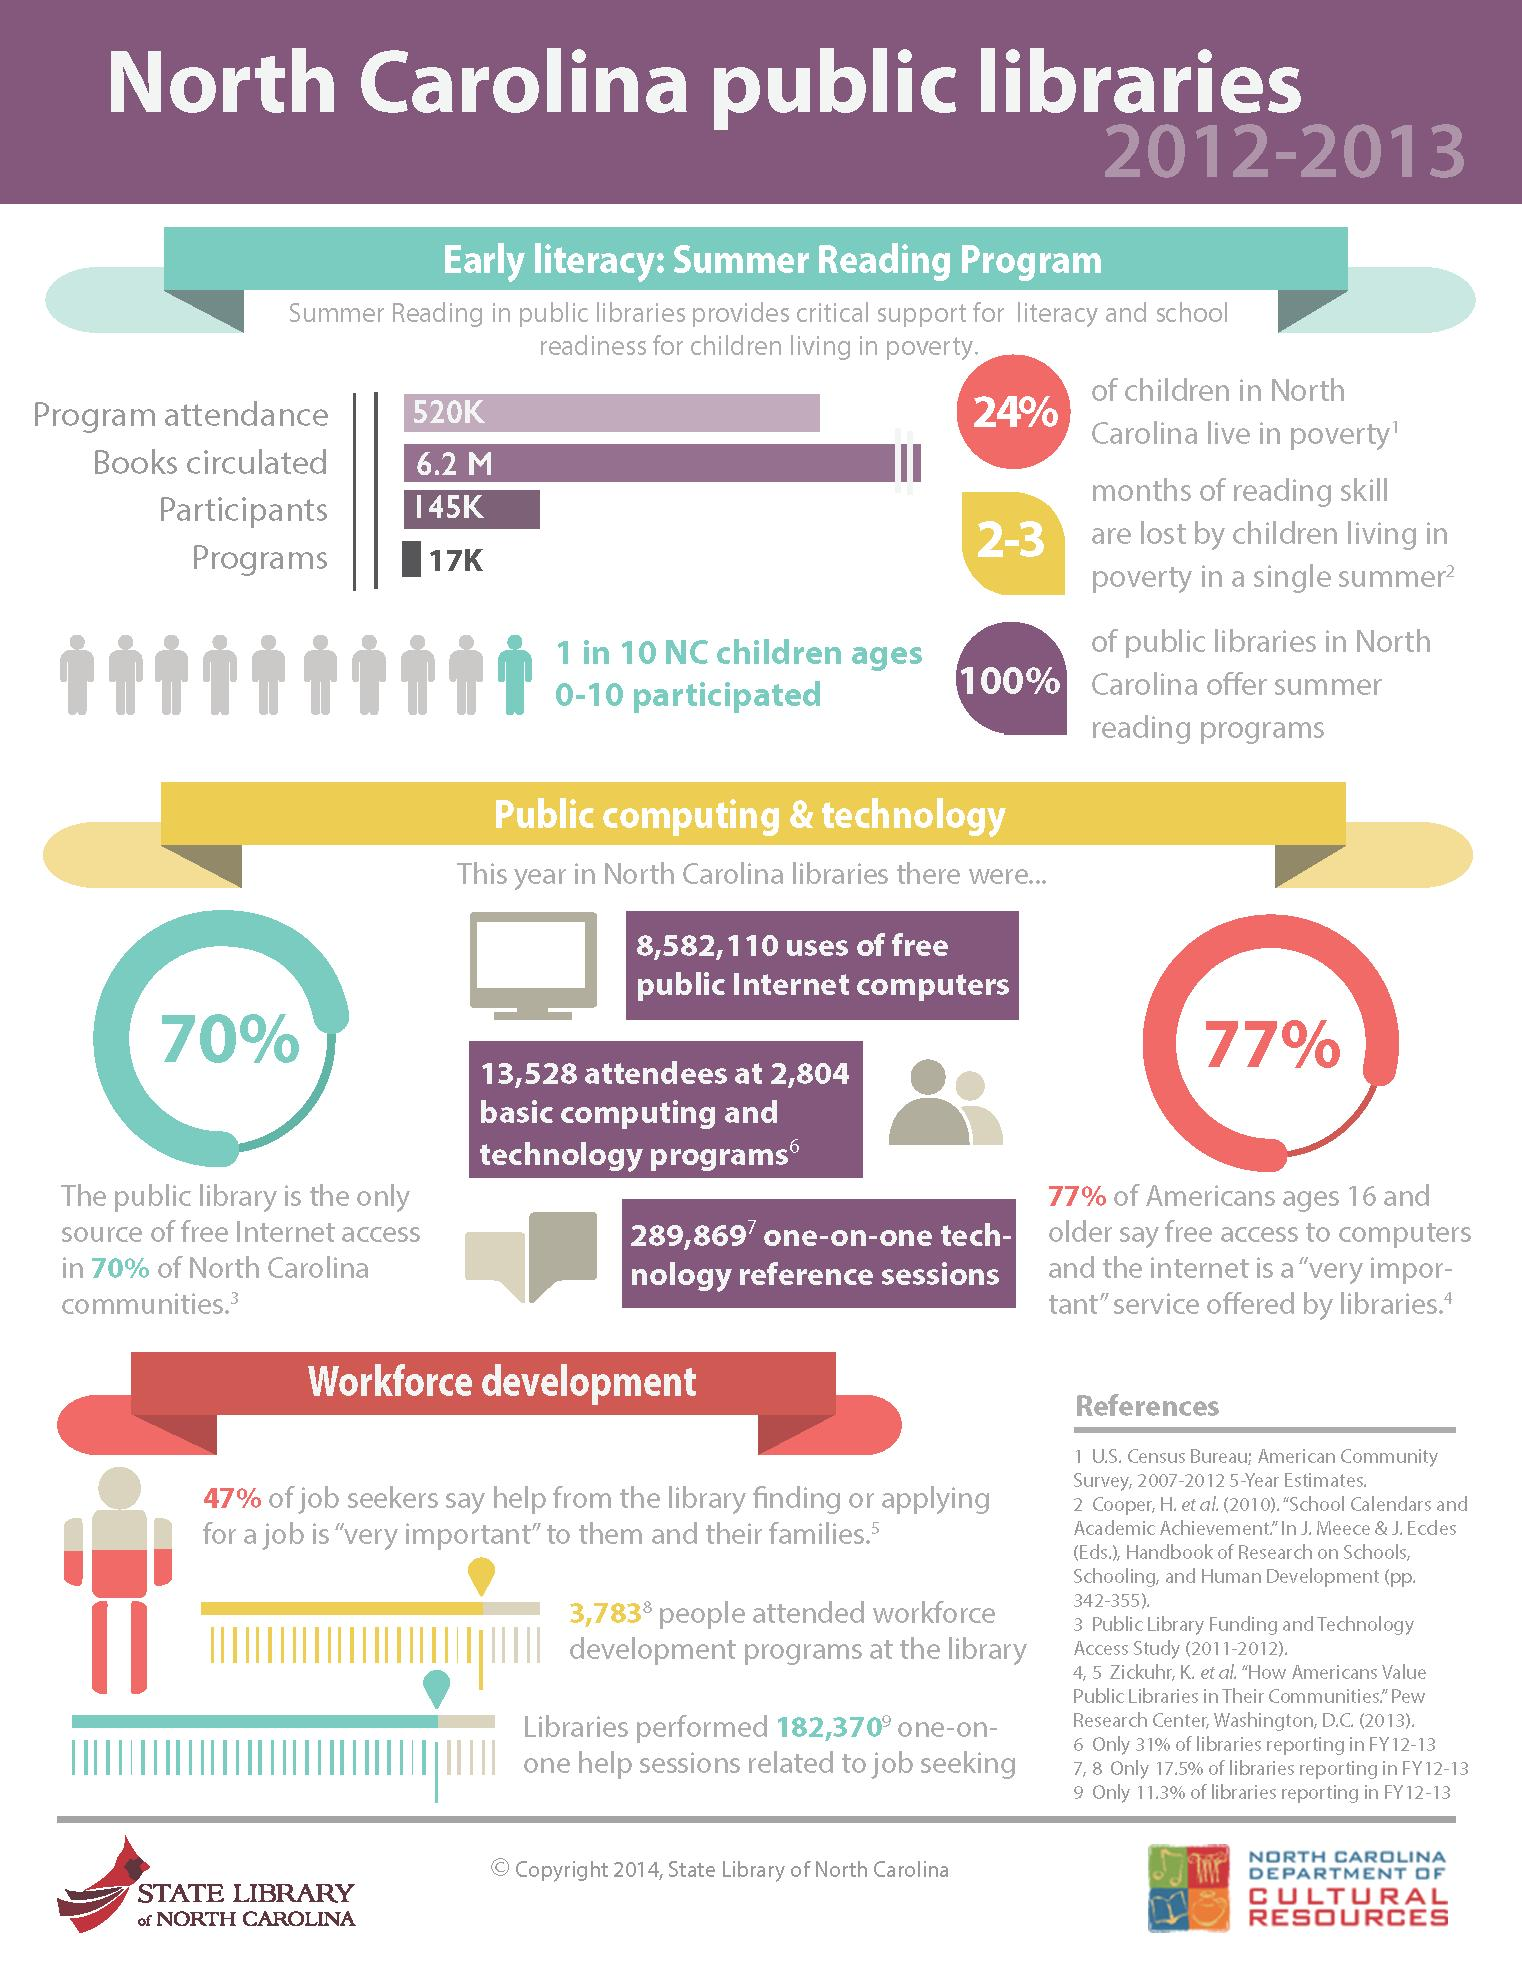Give some essential details in this illustration. The public library serves as the sole source of free internet access for the majority of communities in North Carolina. In 2020, public libraries facilitated a total of 289,869 technology reference sessions. A study found that 77% of people believed that free access to computers and the internet was a very important service provided by libraries. 